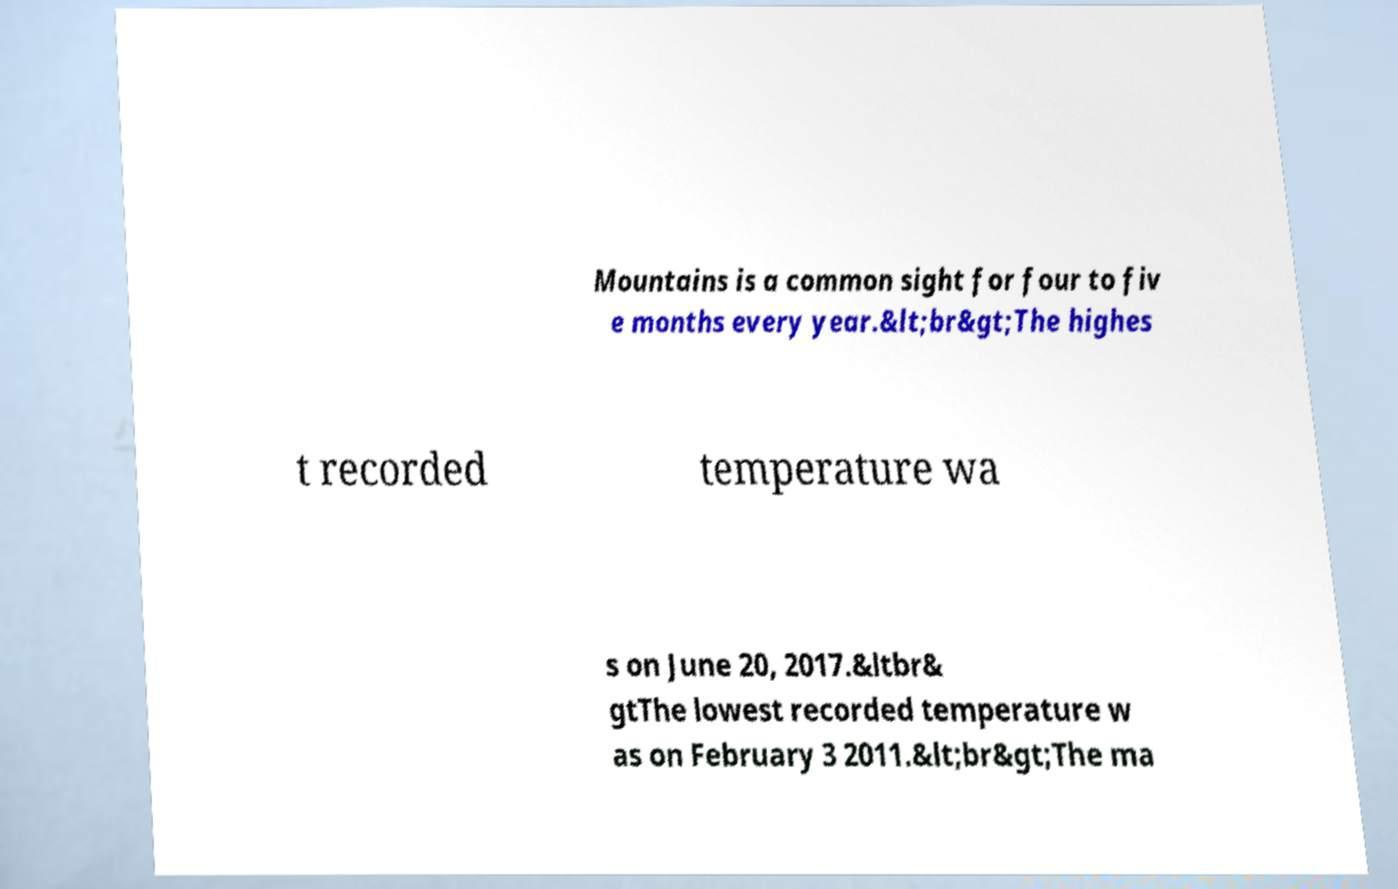I need the written content from this picture converted into text. Can you do that? Mountains is a common sight for four to fiv e months every year.&lt;br&gt;The highes t recorded temperature wa s on June 20, 2017.&ltbr& gtThe lowest recorded temperature w as on February 3 2011.&lt;br&gt;The ma 